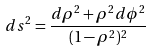Convert formula to latex. <formula><loc_0><loc_0><loc_500><loc_500>d s ^ { 2 } = \frac { d \rho ^ { 2 } + \rho ^ { 2 } d \phi ^ { 2 } } { ( 1 - \rho ^ { 2 } ) ^ { 2 } }</formula> 